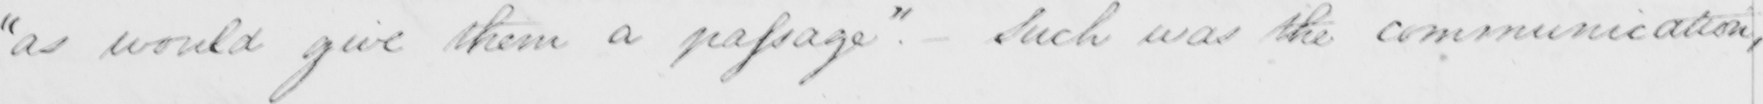What text is written in this handwritten line? " as would give them a passage "  . - Such was the communication , 